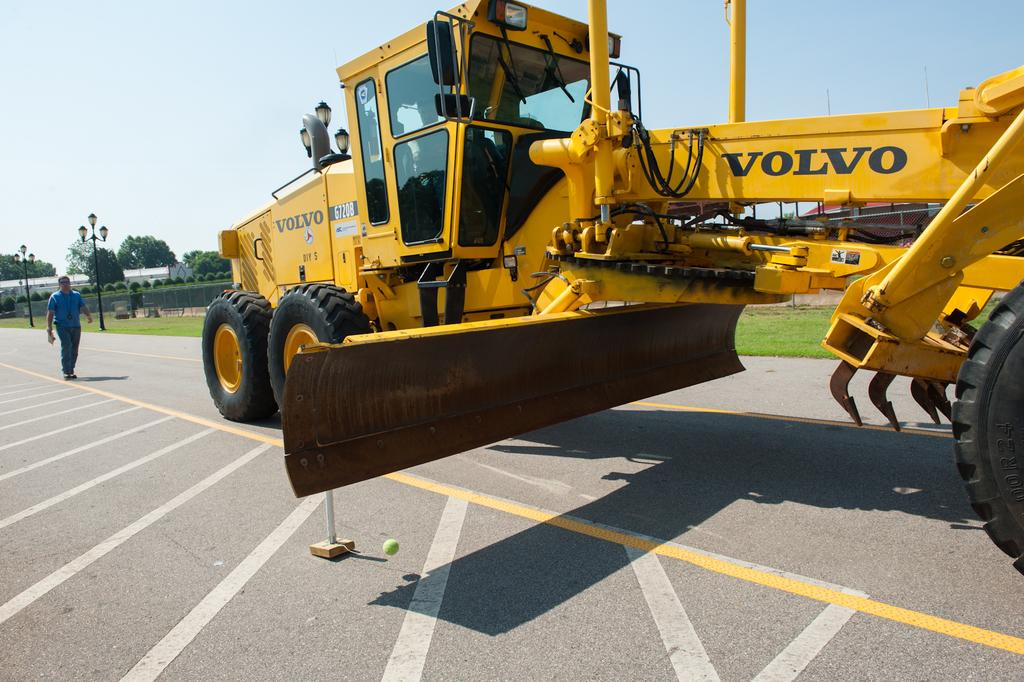Provide a one-sentence caption for the provided image. the volvo piece of machinery is yellow and huge. 